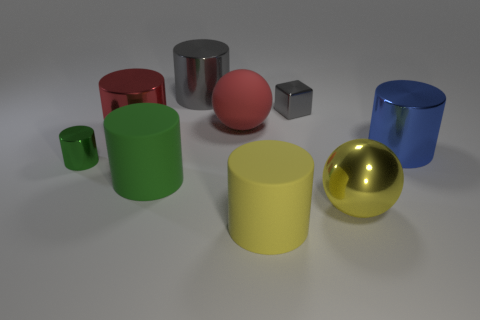Subtract all large red metal cylinders. How many cylinders are left? 5 Subtract 3 cylinders. How many cylinders are left? 3 Subtract all gray cylinders. How many cylinders are left? 5 Subtract all gray cylinders. Subtract all gray cubes. How many cylinders are left? 5 Add 1 tiny purple shiny spheres. How many objects exist? 10 Subtract all cubes. How many objects are left? 8 Add 4 red metallic cylinders. How many red metallic cylinders exist? 5 Subtract 0 cyan cylinders. How many objects are left? 9 Subtract all large green metallic spheres. Subtract all yellow shiny balls. How many objects are left? 8 Add 7 large green objects. How many large green objects are left? 8 